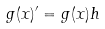Convert formula to latex. <formula><loc_0><loc_0><loc_500><loc_500>g ( x ) ^ { \prime } = g ( x ) h</formula> 